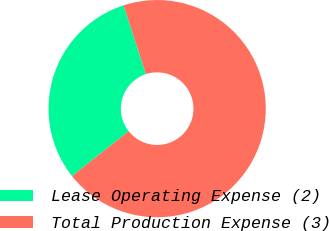Convert chart. <chart><loc_0><loc_0><loc_500><loc_500><pie_chart><fcel>Lease Operating Expense (2)<fcel>Total Production Expense (3)<nl><fcel>30.65%<fcel>69.35%<nl></chart> 